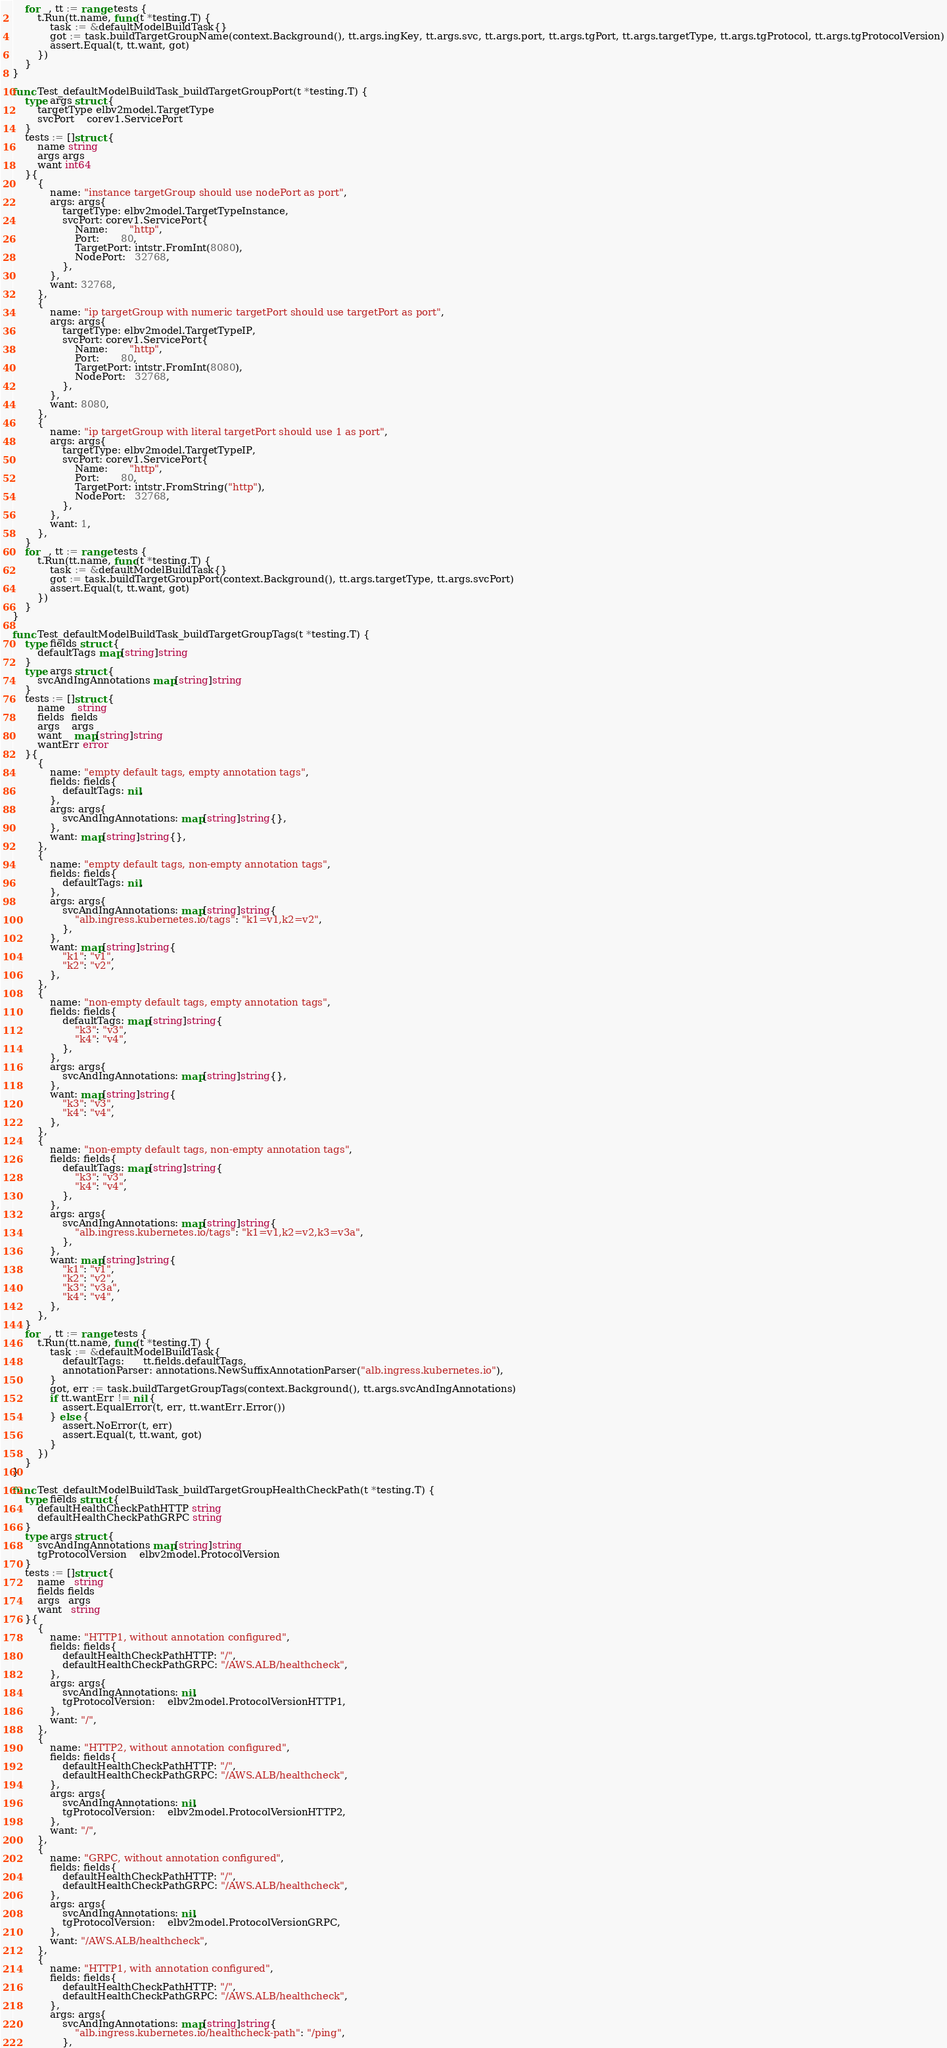Convert code to text. <code><loc_0><loc_0><loc_500><loc_500><_Go_>	for _, tt := range tests {
		t.Run(tt.name, func(t *testing.T) {
			task := &defaultModelBuildTask{}
			got := task.buildTargetGroupName(context.Background(), tt.args.ingKey, tt.args.svc, tt.args.port, tt.args.tgPort, tt.args.targetType, tt.args.tgProtocol, tt.args.tgProtocolVersion)
			assert.Equal(t, tt.want, got)
		})
	}
}

func Test_defaultModelBuildTask_buildTargetGroupPort(t *testing.T) {
	type args struct {
		targetType elbv2model.TargetType
		svcPort    corev1.ServicePort
	}
	tests := []struct {
		name string
		args args
		want int64
	}{
		{
			name: "instance targetGroup should use nodePort as port",
			args: args{
				targetType: elbv2model.TargetTypeInstance,
				svcPort: corev1.ServicePort{
					Name:       "http",
					Port:       80,
					TargetPort: intstr.FromInt(8080),
					NodePort:   32768,
				},
			},
			want: 32768,
		},
		{
			name: "ip targetGroup with numeric targetPort should use targetPort as port",
			args: args{
				targetType: elbv2model.TargetTypeIP,
				svcPort: corev1.ServicePort{
					Name:       "http",
					Port:       80,
					TargetPort: intstr.FromInt(8080),
					NodePort:   32768,
				},
			},
			want: 8080,
		},
		{
			name: "ip targetGroup with literal targetPort should use 1 as port",
			args: args{
				targetType: elbv2model.TargetTypeIP,
				svcPort: corev1.ServicePort{
					Name:       "http",
					Port:       80,
					TargetPort: intstr.FromString("http"),
					NodePort:   32768,
				},
			},
			want: 1,
		},
	}
	for _, tt := range tests {
		t.Run(tt.name, func(t *testing.T) {
			task := &defaultModelBuildTask{}
			got := task.buildTargetGroupPort(context.Background(), tt.args.targetType, tt.args.svcPort)
			assert.Equal(t, tt.want, got)
		})
	}
}

func Test_defaultModelBuildTask_buildTargetGroupTags(t *testing.T) {
	type fields struct {
		defaultTags map[string]string
	}
	type args struct {
		svcAndIngAnnotations map[string]string
	}
	tests := []struct {
		name    string
		fields  fields
		args    args
		want    map[string]string
		wantErr error
	}{
		{
			name: "empty default tags, empty annotation tags",
			fields: fields{
				defaultTags: nil,
			},
			args: args{
				svcAndIngAnnotations: map[string]string{},
			},
			want: map[string]string{},
		},
		{
			name: "empty default tags, non-empty annotation tags",
			fields: fields{
				defaultTags: nil,
			},
			args: args{
				svcAndIngAnnotations: map[string]string{
					"alb.ingress.kubernetes.io/tags": "k1=v1,k2=v2",
				},
			},
			want: map[string]string{
				"k1": "v1",
				"k2": "v2",
			},
		},
		{
			name: "non-empty default tags, empty annotation tags",
			fields: fields{
				defaultTags: map[string]string{
					"k3": "v3",
					"k4": "v4",
				},
			},
			args: args{
				svcAndIngAnnotations: map[string]string{},
			},
			want: map[string]string{
				"k3": "v3",
				"k4": "v4",
			},
		},
		{
			name: "non-empty default tags, non-empty annotation tags",
			fields: fields{
				defaultTags: map[string]string{
					"k3": "v3",
					"k4": "v4",
				},
			},
			args: args{
				svcAndIngAnnotations: map[string]string{
					"alb.ingress.kubernetes.io/tags": "k1=v1,k2=v2,k3=v3a",
				},
			},
			want: map[string]string{
				"k1": "v1",
				"k2": "v2",
				"k3": "v3a",
				"k4": "v4",
			},
		},
	}
	for _, tt := range tests {
		t.Run(tt.name, func(t *testing.T) {
			task := &defaultModelBuildTask{
				defaultTags:      tt.fields.defaultTags,
				annotationParser: annotations.NewSuffixAnnotationParser("alb.ingress.kubernetes.io"),
			}
			got, err := task.buildTargetGroupTags(context.Background(), tt.args.svcAndIngAnnotations)
			if tt.wantErr != nil {
				assert.EqualError(t, err, tt.wantErr.Error())
			} else {
				assert.NoError(t, err)
				assert.Equal(t, tt.want, got)
			}
		})
	}
}

func Test_defaultModelBuildTask_buildTargetGroupHealthCheckPath(t *testing.T) {
	type fields struct {
		defaultHealthCheckPathHTTP string
		defaultHealthCheckPathGRPC string
	}
	type args struct {
		svcAndIngAnnotations map[string]string
		tgProtocolVersion    elbv2model.ProtocolVersion
	}
	tests := []struct {
		name   string
		fields fields
		args   args
		want   string
	}{
		{
			name: "HTTP1, without annotation configured",
			fields: fields{
				defaultHealthCheckPathHTTP: "/",
				defaultHealthCheckPathGRPC: "/AWS.ALB/healthcheck",
			},
			args: args{
				svcAndIngAnnotations: nil,
				tgProtocolVersion:    elbv2model.ProtocolVersionHTTP1,
			},
			want: "/",
		},
		{
			name: "HTTP2, without annotation configured",
			fields: fields{
				defaultHealthCheckPathHTTP: "/",
				defaultHealthCheckPathGRPC: "/AWS.ALB/healthcheck",
			},
			args: args{
				svcAndIngAnnotations: nil,
				tgProtocolVersion:    elbv2model.ProtocolVersionHTTP2,
			},
			want: "/",
		},
		{
			name: "GRPC, without annotation configured",
			fields: fields{
				defaultHealthCheckPathHTTP: "/",
				defaultHealthCheckPathGRPC: "/AWS.ALB/healthcheck",
			},
			args: args{
				svcAndIngAnnotations: nil,
				tgProtocolVersion:    elbv2model.ProtocolVersionGRPC,
			},
			want: "/AWS.ALB/healthcheck",
		},
		{
			name: "HTTP1, with annotation configured",
			fields: fields{
				defaultHealthCheckPathHTTP: "/",
				defaultHealthCheckPathGRPC: "/AWS.ALB/healthcheck",
			},
			args: args{
				svcAndIngAnnotations: map[string]string{
					"alb.ingress.kubernetes.io/healthcheck-path": "/ping",
				},</code> 